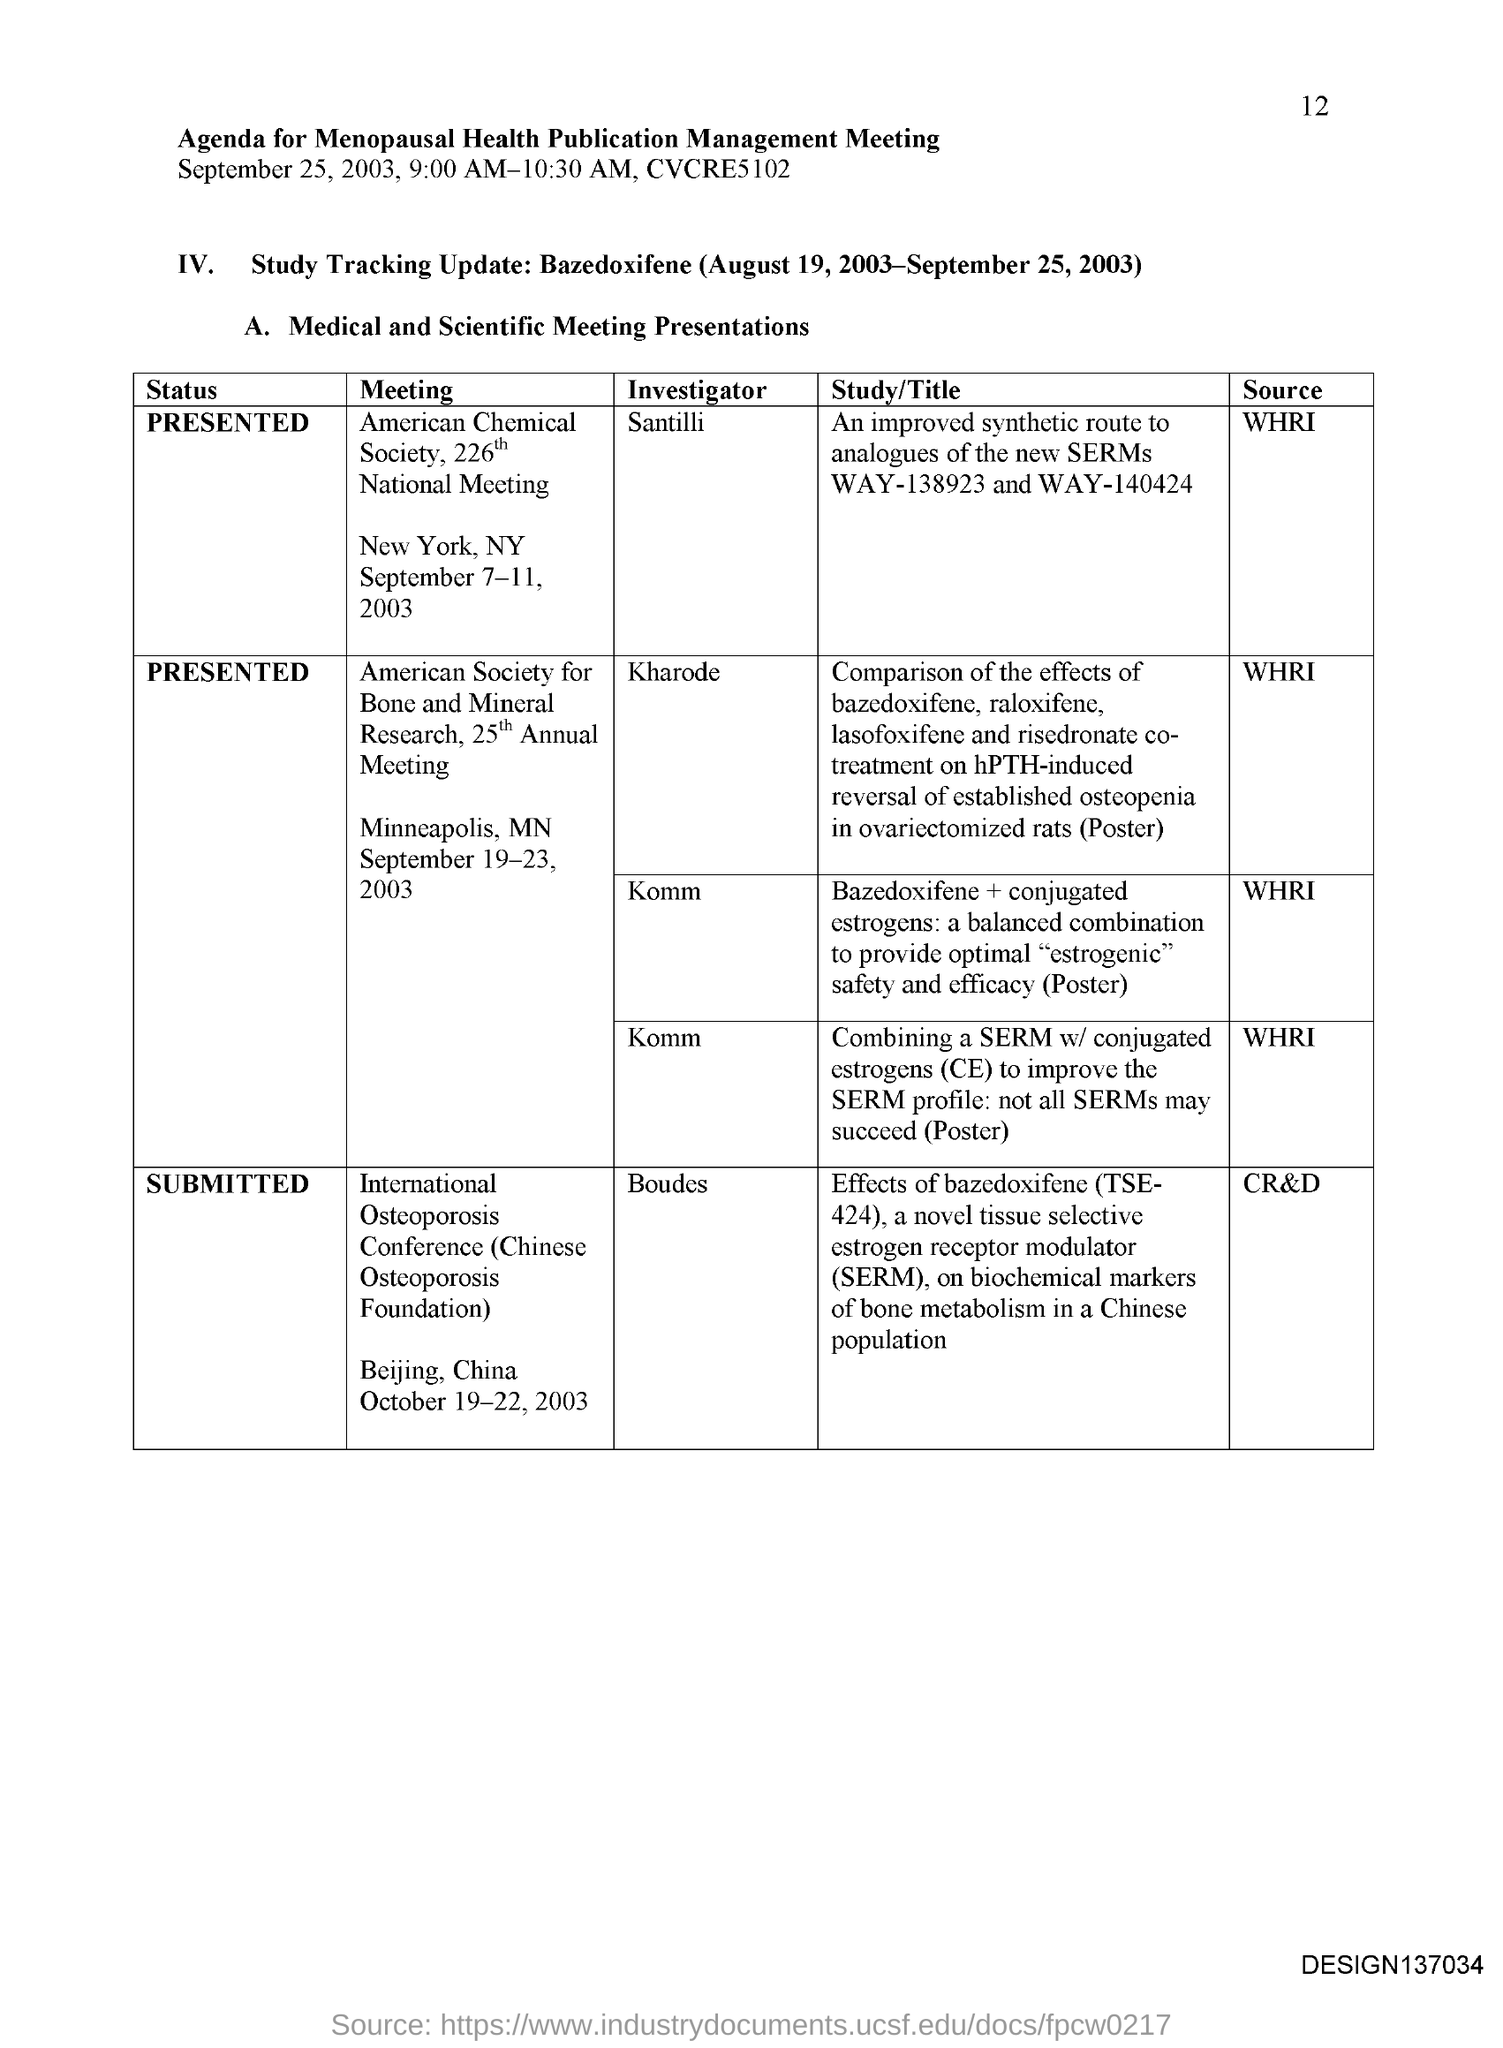Specify some key components in this picture. The page number is 12. The American Society for Bone and Mineral Research held its 25th annual meeting, which was presented. The International Osteoporosis Conference has been submitted. The American Chemical Society held its 226th national meeting and the presentation of the status was part of the event. The investigator of the American Chemical Society is Santilli. 